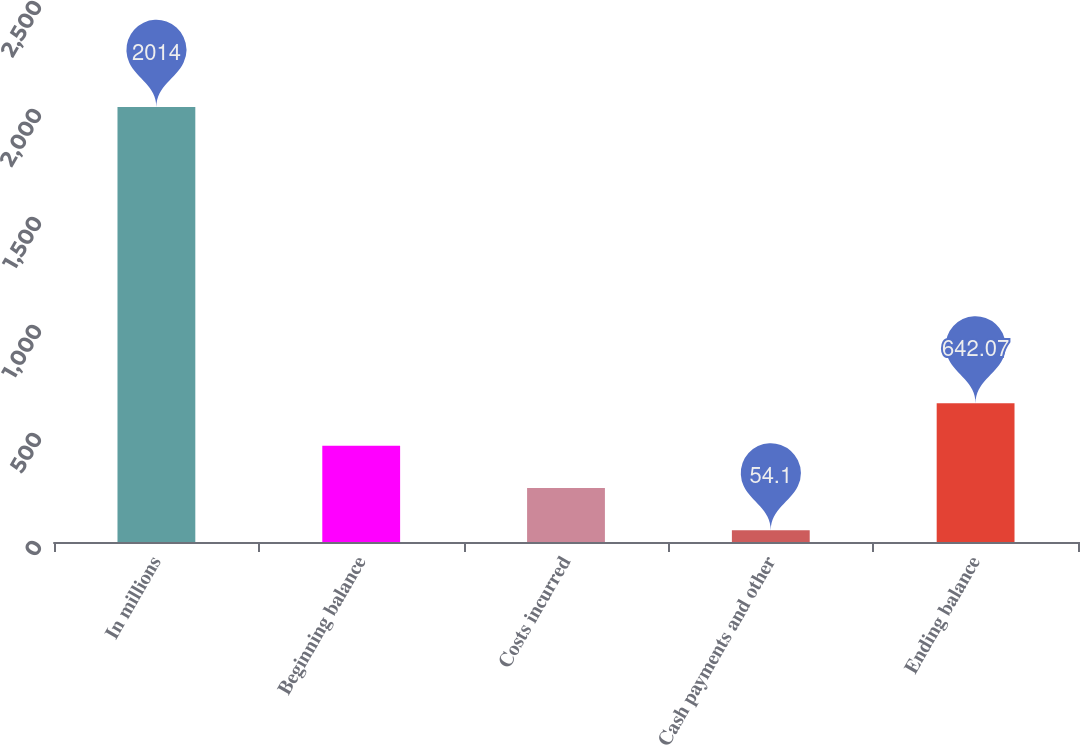Convert chart to OTSL. <chart><loc_0><loc_0><loc_500><loc_500><bar_chart><fcel>In millions<fcel>Beginning balance<fcel>Costs incurred<fcel>Cash payments and other<fcel>Ending balance<nl><fcel>2014<fcel>446.08<fcel>250.09<fcel>54.1<fcel>642.07<nl></chart> 